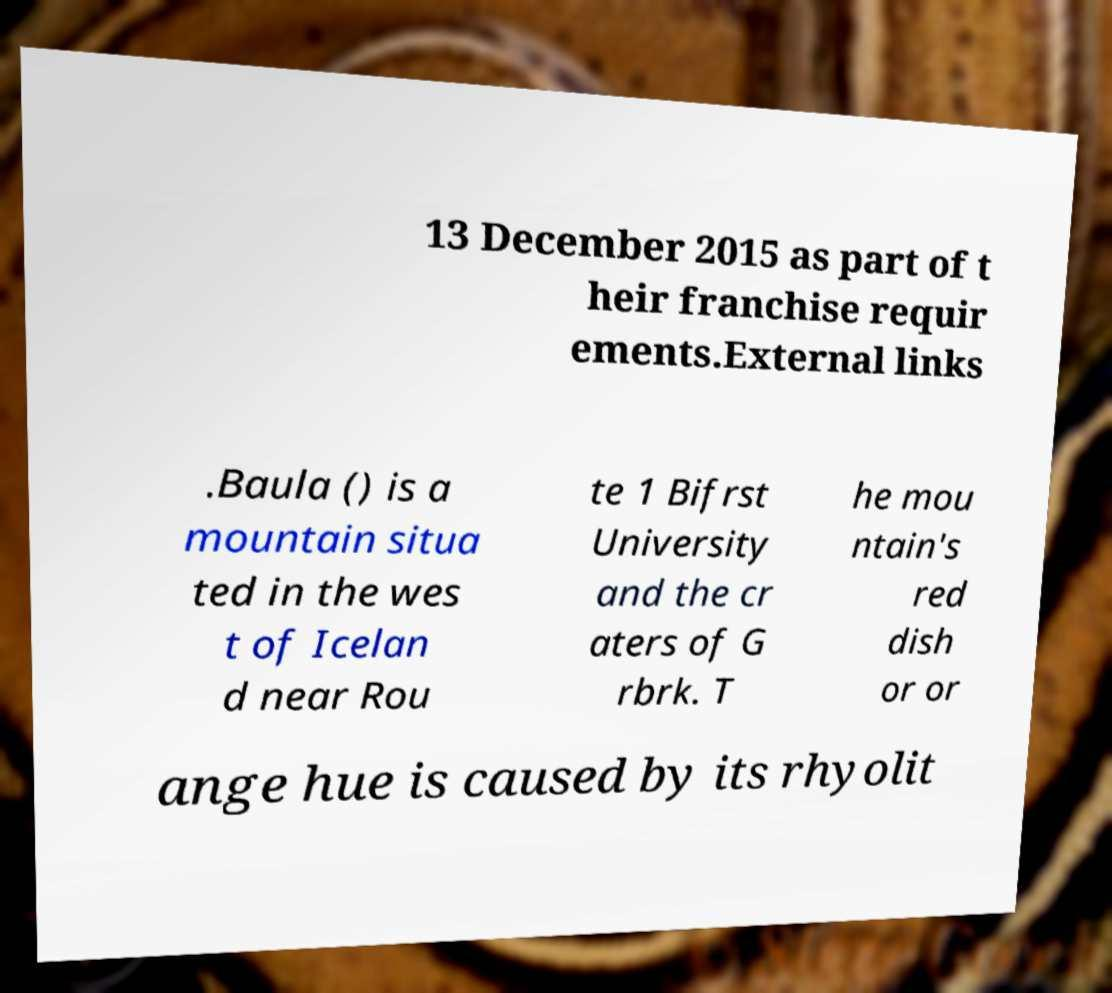For documentation purposes, I need the text within this image transcribed. Could you provide that? 13 December 2015 as part of t heir franchise requir ements.External links .Baula () is a mountain situa ted in the wes t of Icelan d near Rou te 1 Bifrst University and the cr aters of G rbrk. T he mou ntain's red dish or or ange hue is caused by its rhyolit 